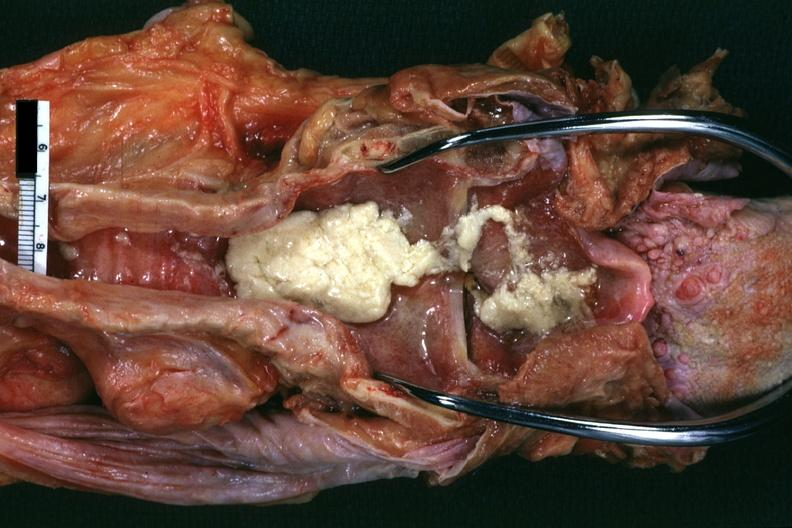s larynx present?
Answer the question using a single word or phrase. Yes 